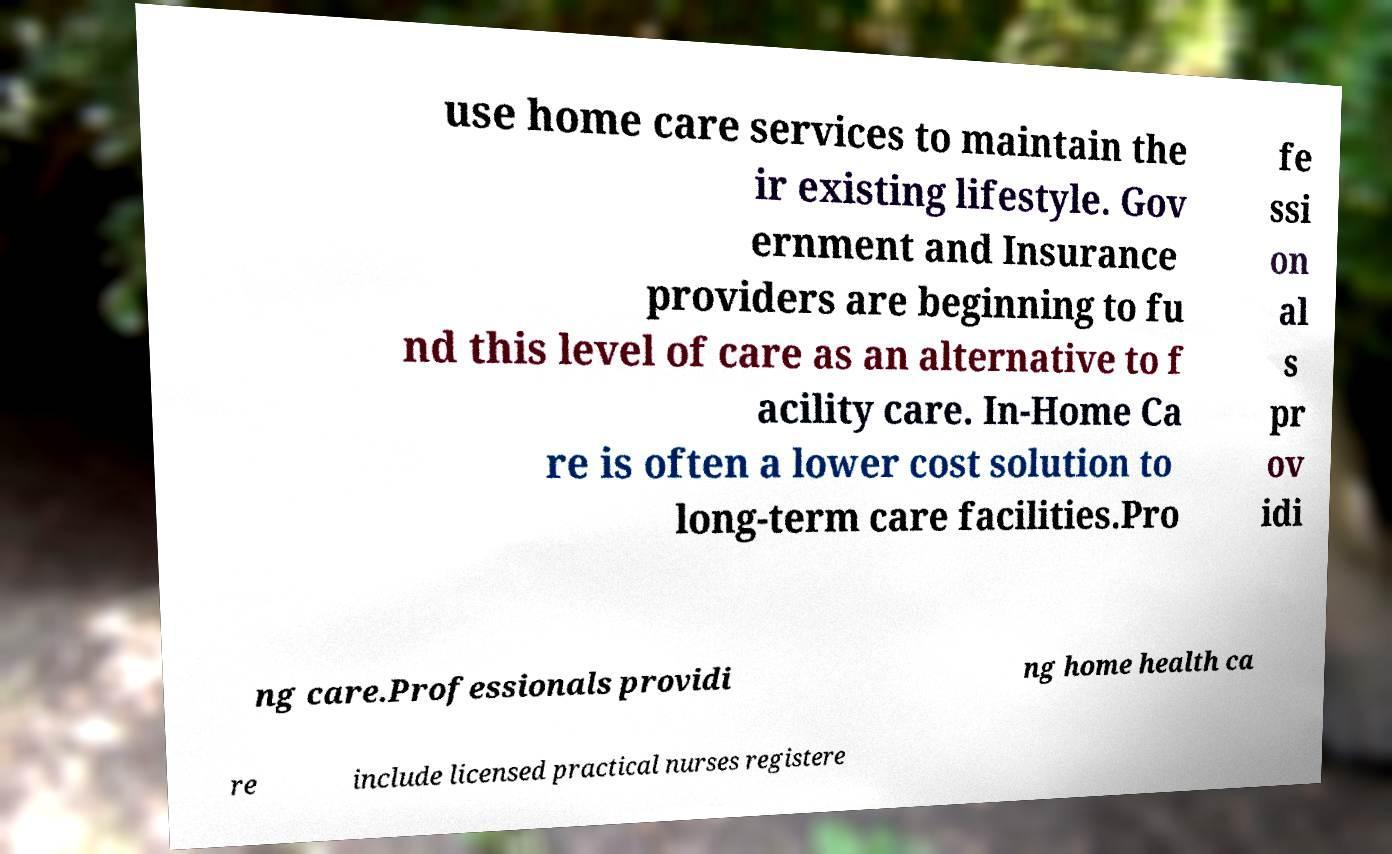Can you accurately transcribe the text from the provided image for me? use home care services to maintain the ir existing lifestyle. Gov ernment and Insurance providers are beginning to fu nd this level of care as an alternative to f acility care. In-Home Ca re is often a lower cost solution to long-term care facilities.Pro fe ssi on al s pr ov idi ng care.Professionals providi ng home health ca re include licensed practical nurses registere 